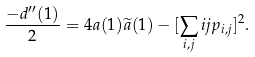Convert formula to latex. <formula><loc_0><loc_0><loc_500><loc_500>\frac { - d ^ { \prime \prime } ( 1 ) } { 2 } = 4 a ( 1 ) \widetilde { a } ( 1 ) - [ \sum _ { i , j } i j p _ { i , j } ] ^ { 2 } .</formula> 